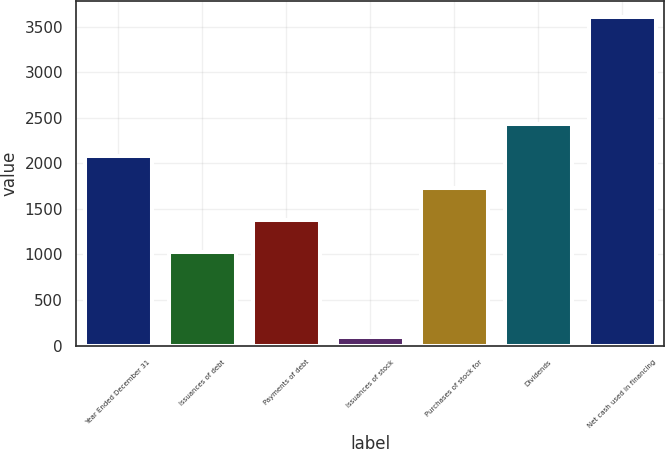<chart> <loc_0><loc_0><loc_500><loc_500><bar_chart><fcel>Year Ended December 31<fcel>Issuances of debt<fcel>Payments of debt<fcel>Issuances of stock<fcel>Purchases of stock for<fcel>Dividends<fcel>Net cash used in financing<nl><fcel>2076.9<fcel>1026<fcel>1376.3<fcel>98<fcel>1726.6<fcel>2427.2<fcel>3601<nl></chart> 